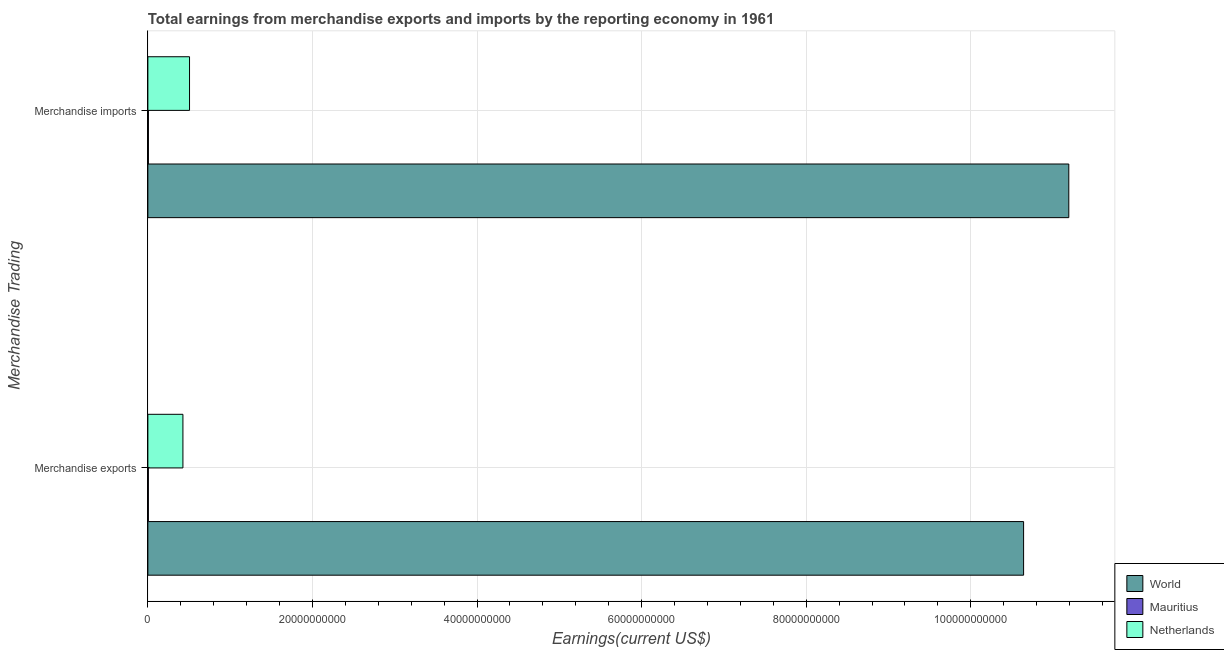How many different coloured bars are there?
Provide a succinct answer. 3. Are the number of bars per tick equal to the number of legend labels?
Ensure brevity in your answer.  Yes. How many bars are there on the 1st tick from the bottom?
Your answer should be compact. 3. What is the label of the 1st group of bars from the top?
Your answer should be compact. Merchandise imports. What is the earnings from merchandise exports in Mauritius?
Provide a short and direct response. 6.04e+07. Across all countries, what is the maximum earnings from merchandise imports?
Offer a very short reply. 1.12e+11. Across all countries, what is the minimum earnings from merchandise exports?
Your answer should be compact. 6.04e+07. In which country was the earnings from merchandise imports maximum?
Offer a very short reply. World. In which country was the earnings from merchandise imports minimum?
Offer a terse response. Mauritius. What is the total earnings from merchandise exports in the graph?
Offer a very short reply. 1.11e+11. What is the difference between the earnings from merchandise exports in Netherlands and that in World?
Your answer should be compact. -1.02e+11. What is the difference between the earnings from merchandise imports in Mauritius and the earnings from merchandise exports in World?
Your answer should be very brief. -1.06e+11. What is the average earnings from merchandise imports per country?
Make the answer very short. 3.90e+1. What is the difference between the earnings from merchandise exports and earnings from merchandise imports in World?
Your response must be concise. -5.49e+09. What is the ratio of the earnings from merchandise exports in World to that in Netherlands?
Your response must be concise. 24.98. Is the earnings from merchandise imports in Netherlands less than that in Mauritius?
Provide a short and direct response. No. In how many countries, is the earnings from merchandise imports greater than the average earnings from merchandise imports taken over all countries?
Offer a very short reply. 1. What does the 2nd bar from the top in Merchandise imports represents?
Give a very brief answer. Mauritius. What does the 2nd bar from the bottom in Merchandise imports represents?
Your answer should be compact. Mauritius. Are all the bars in the graph horizontal?
Offer a terse response. Yes. What is the difference between two consecutive major ticks on the X-axis?
Your answer should be very brief. 2.00e+1. Are the values on the major ticks of X-axis written in scientific E-notation?
Offer a very short reply. No. Does the graph contain grids?
Provide a short and direct response. Yes. Where does the legend appear in the graph?
Give a very brief answer. Bottom right. What is the title of the graph?
Offer a very short reply. Total earnings from merchandise exports and imports by the reporting economy in 1961. Does "Sweden" appear as one of the legend labels in the graph?
Keep it short and to the point. No. What is the label or title of the X-axis?
Make the answer very short. Earnings(current US$). What is the label or title of the Y-axis?
Offer a very short reply. Merchandise Trading. What is the Earnings(current US$) of World in Merchandise exports?
Offer a very short reply. 1.06e+11. What is the Earnings(current US$) in Mauritius in Merchandise exports?
Your response must be concise. 6.04e+07. What is the Earnings(current US$) in Netherlands in Merchandise exports?
Your answer should be compact. 4.26e+09. What is the Earnings(current US$) in World in Merchandise imports?
Provide a succinct answer. 1.12e+11. What is the Earnings(current US$) in Mauritius in Merchandise imports?
Keep it short and to the point. 6.59e+07. What is the Earnings(current US$) of Netherlands in Merchandise imports?
Make the answer very short. 5.06e+09. Across all Merchandise Trading, what is the maximum Earnings(current US$) of World?
Give a very brief answer. 1.12e+11. Across all Merchandise Trading, what is the maximum Earnings(current US$) in Mauritius?
Offer a very short reply. 6.59e+07. Across all Merchandise Trading, what is the maximum Earnings(current US$) in Netherlands?
Keep it short and to the point. 5.06e+09. Across all Merchandise Trading, what is the minimum Earnings(current US$) in World?
Offer a very short reply. 1.06e+11. Across all Merchandise Trading, what is the minimum Earnings(current US$) of Mauritius?
Provide a succinct answer. 6.04e+07. Across all Merchandise Trading, what is the minimum Earnings(current US$) of Netherlands?
Offer a terse response. 4.26e+09. What is the total Earnings(current US$) in World in the graph?
Give a very brief answer. 2.18e+11. What is the total Earnings(current US$) in Mauritius in the graph?
Your response must be concise. 1.26e+08. What is the total Earnings(current US$) of Netherlands in the graph?
Ensure brevity in your answer.  9.32e+09. What is the difference between the Earnings(current US$) of World in Merchandise exports and that in Merchandise imports?
Provide a succinct answer. -5.49e+09. What is the difference between the Earnings(current US$) in Mauritius in Merchandise exports and that in Merchandise imports?
Give a very brief answer. -5.50e+06. What is the difference between the Earnings(current US$) in Netherlands in Merchandise exports and that in Merchandise imports?
Ensure brevity in your answer.  -8.04e+08. What is the difference between the Earnings(current US$) in World in Merchandise exports and the Earnings(current US$) in Mauritius in Merchandise imports?
Your answer should be compact. 1.06e+11. What is the difference between the Earnings(current US$) of World in Merchandise exports and the Earnings(current US$) of Netherlands in Merchandise imports?
Your answer should be compact. 1.01e+11. What is the difference between the Earnings(current US$) in Mauritius in Merchandise exports and the Earnings(current US$) in Netherlands in Merchandise imports?
Your answer should be very brief. -5.00e+09. What is the average Earnings(current US$) in World per Merchandise Trading?
Keep it short and to the point. 1.09e+11. What is the average Earnings(current US$) in Mauritius per Merchandise Trading?
Provide a short and direct response. 6.32e+07. What is the average Earnings(current US$) in Netherlands per Merchandise Trading?
Give a very brief answer. 4.66e+09. What is the difference between the Earnings(current US$) of World and Earnings(current US$) of Mauritius in Merchandise exports?
Offer a terse response. 1.06e+11. What is the difference between the Earnings(current US$) in World and Earnings(current US$) in Netherlands in Merchandise exports?
Give a very brief answer. 1.02e+11. What is the difference between the Earnings(current US$) in Mauritius and Earnings(current US$) in Netherlands in Merchandise exports?
Make the answer very short. -4.20e+09. What is the difference between the Earnings(current US$) of World and Earnings(current US$) of Mauritius in Merchandise imports?
Your answer should be compact. 1.12e+11. What is the difference between the Earnings(current US$) in World and Earnings(current US$) in Netherlands in Merchandise imports?
Offer a very short reply. 1.07e+11. What is the difference between the Earnings(current US$) in Mauritius and Earnings(current US$) in Netherlands in Merchandise imports?
Your answer should be compact. -5.00e+09. What is the ratio of the Earnings(current US$) of World in Merchandise exports to that in Merchandise imports?
Provide a succinct answer. 0.95. What is the ratio of the Earnings(current US$) of Mauritius in Merchandise exports to that in Merchandise imports?
Give a very brief answer. 0.92. What is the ratio of the Earnings(current US$) of Netherlands in Merchandise exports to that in Merchandise imports?
Keep it short and to the point. 0.84. What is the difference between the highest and the second highest Earnings(current US$) in World?
Your answer should be compact. 5.49e+09. What is the difference between the highest and the second highest Earnings(current US$) of Mauritius?
Offer a very short reply. 5.50e+06. What is the difference between the highest and the second highest Earnings(current US$) in Netherlands?
Your answer should be very brief. 8.04e+08. What is the difference between the highest and the lowest Earnings(current US$) of World?
Make the answer very short. 5.49e+09. What is the difference between the highest and the lowest Earnings(current US$) in Mauritius?
Provide a succinct answer. 5.50e+06. What is the difference between the highest and the lowest Earnings(current US$) of Netherlands?
Provide a succinct answer. 8.04e+08. 